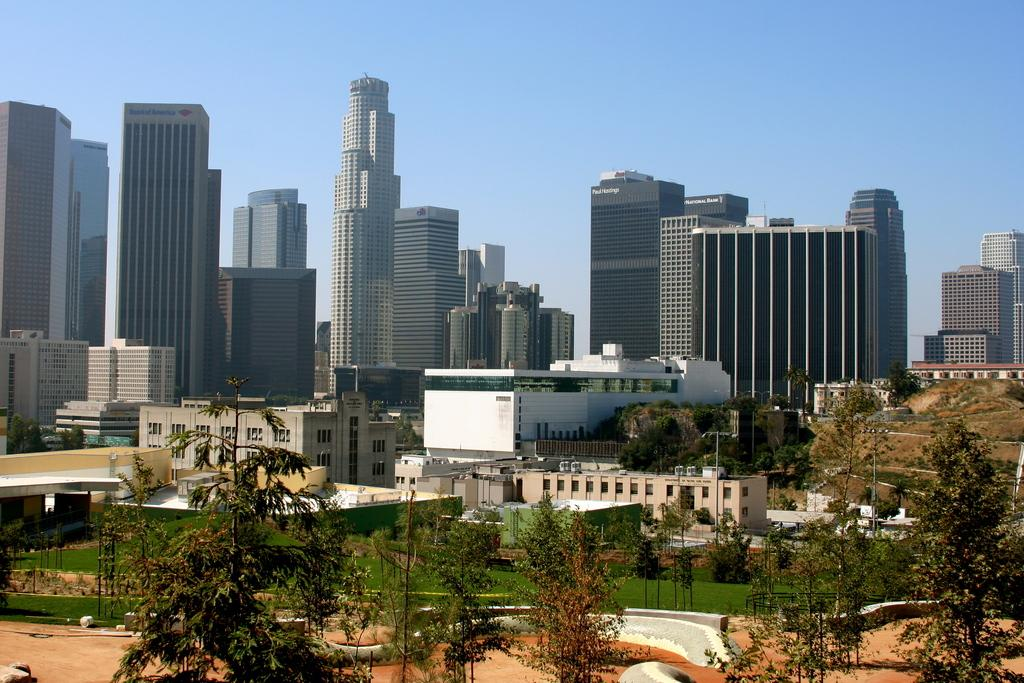What type of structures can be seen in the image? There are buildings in the image. What other natural elements are present in the image? There are trees in the image. What part of the natural environment is visible in the image? The sky is visible in the image. Can you hear the argument taking place in the image? There is no argument present in the image; it only contains visual elements such as buildings, trees, and the sky. 